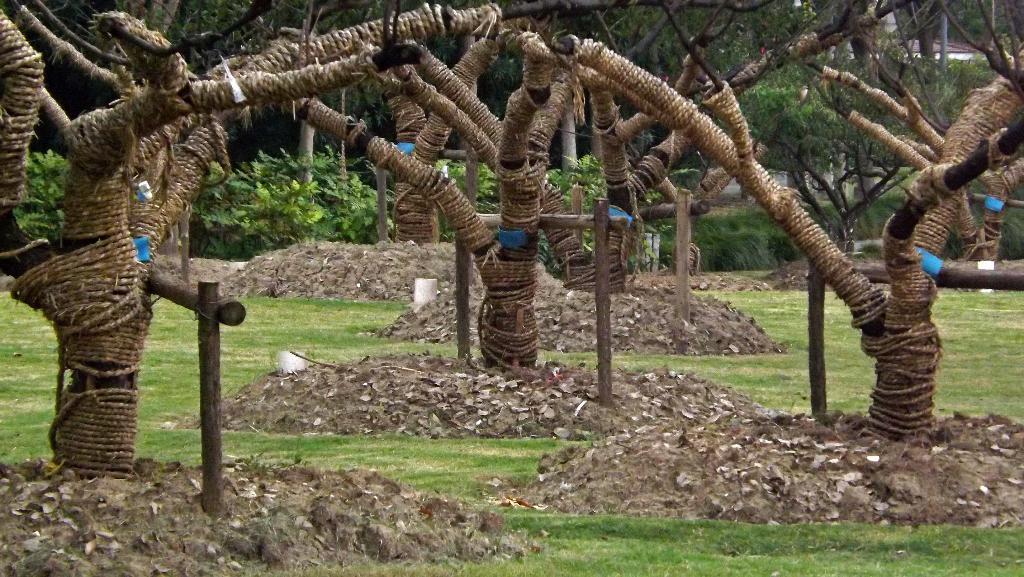In one or two sentences, can you explain what this image depicts? In the center of the image we can see a few trees are attached to the poles. And we can see the trees are wounded with the ropes. At the bottom of the image, we can see the grass, soil and waste particles. In the background, we can see trees and some objects. 